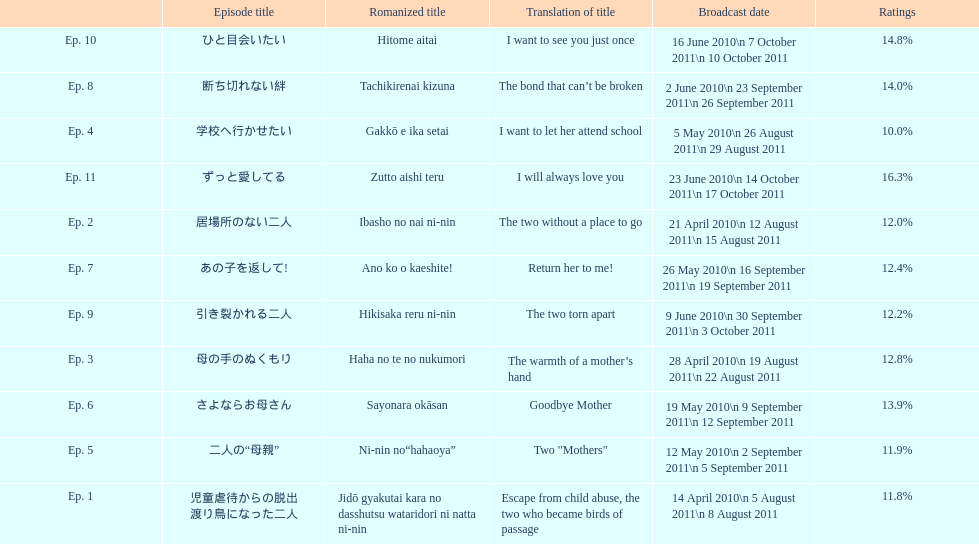How many episodes are listed? 11. 